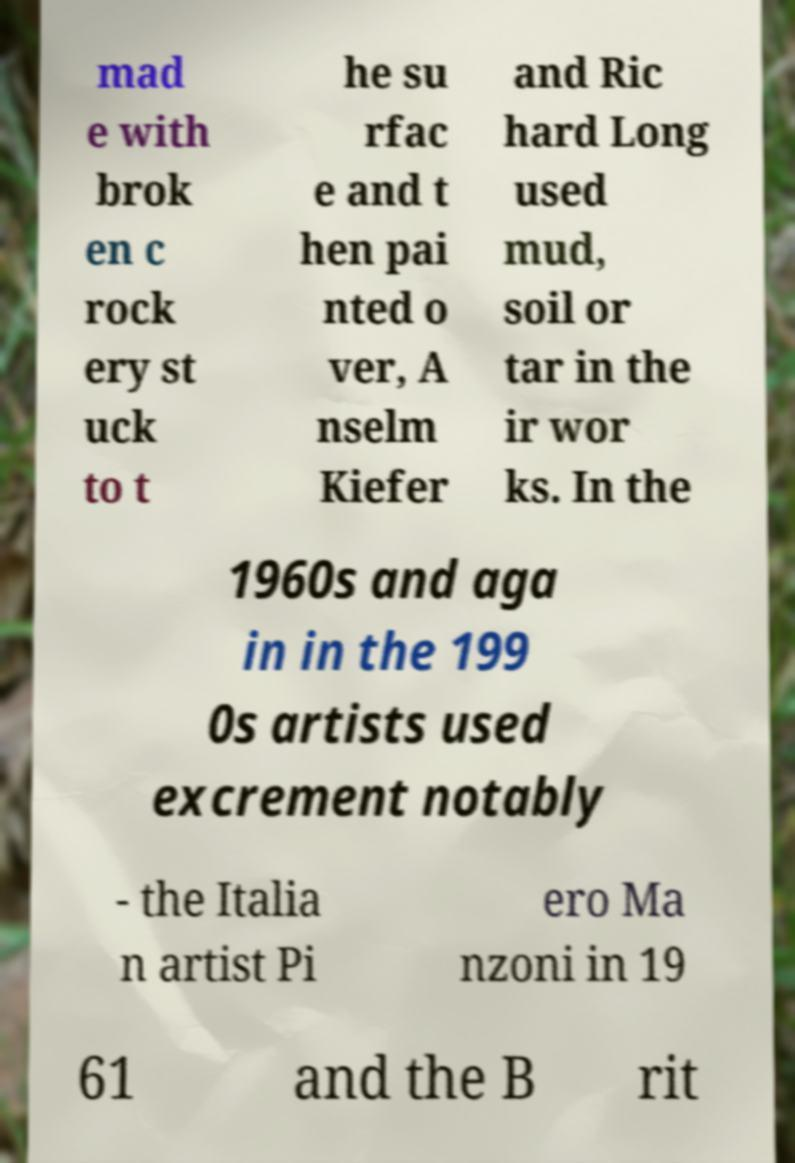Can you read and provide the text displayed in the image?This photo seems to have some interesting text. Can you extract and type it out for me? mad e with brok en c rock ery st uck to t he su rfac e and t hen pai nted o ver, A nselm Kiefer and Ric hard Long used mud, soil or tar in the ir wor ks. In the 1960s and aga in in the 199 0s artists used excrement notably - the Italia n artist Pi ero Ma nzoni in 19 61 and the B rit 